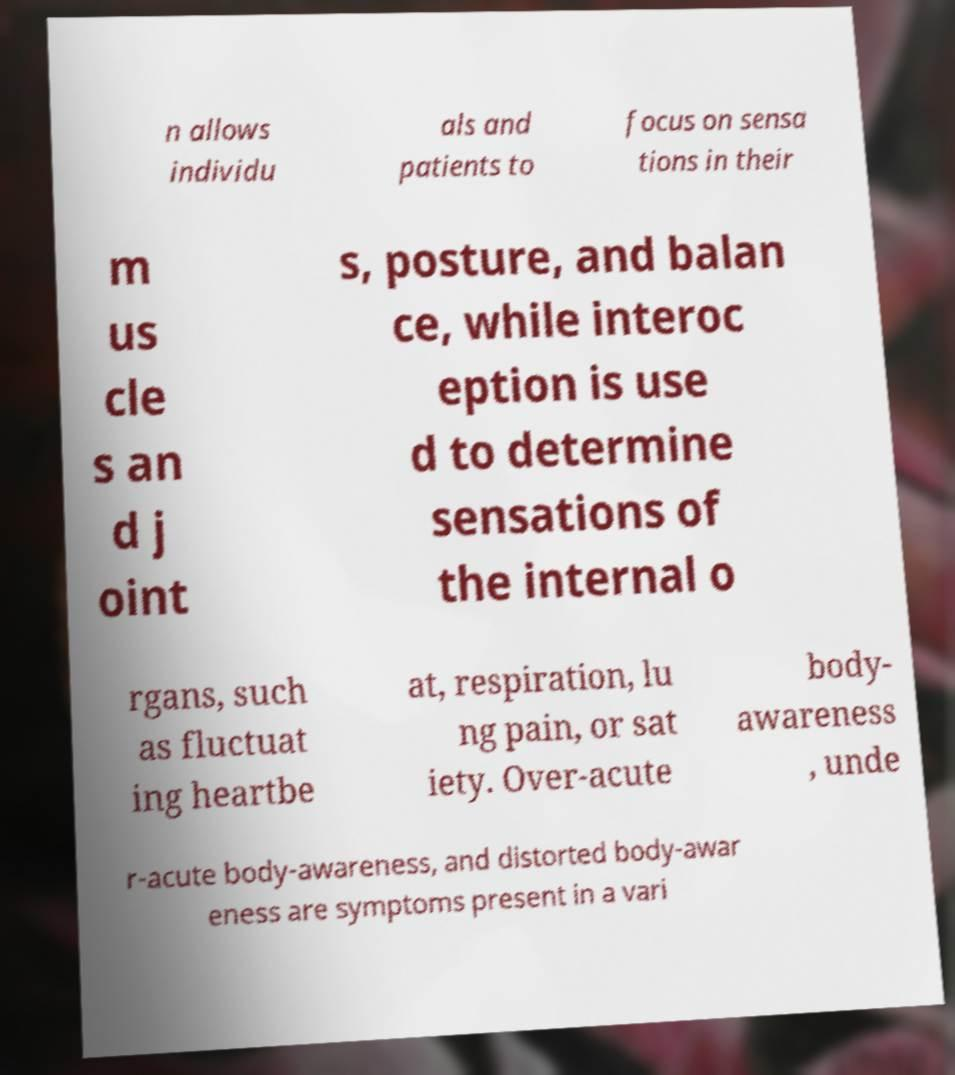I need the written content from this picture converted into text. Can you do that? n allows individu als and patients to focus on sensa tions in their m us cle s an d j oint s, posture, and balan ce, while interoc eption is use d to determine sensations of the internal o rgans, such as fluctuat ing heartbe at, respiration, lu ng pain, or sat iety. Over-acute body- awareness , unde r-acute body-awareness, and distorted body-awar eness are symptoms present in a vari 